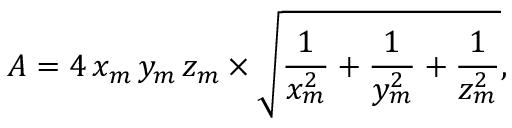Convert formula to latex. <formula><loc_0><loc_0><loc_500><loc_500>A = 4 \, x _ { m } \, y _ { m } \, z _ { m } \times { \sqrt { { \frac { 1 } { x _ { m } ^ { 2 } } } + { \frac { 1 } { y _ { m } ^ { 2 } } } + { \frac { 1 } { z _ { m } ^ { 2 } } } } } ,</formula> 